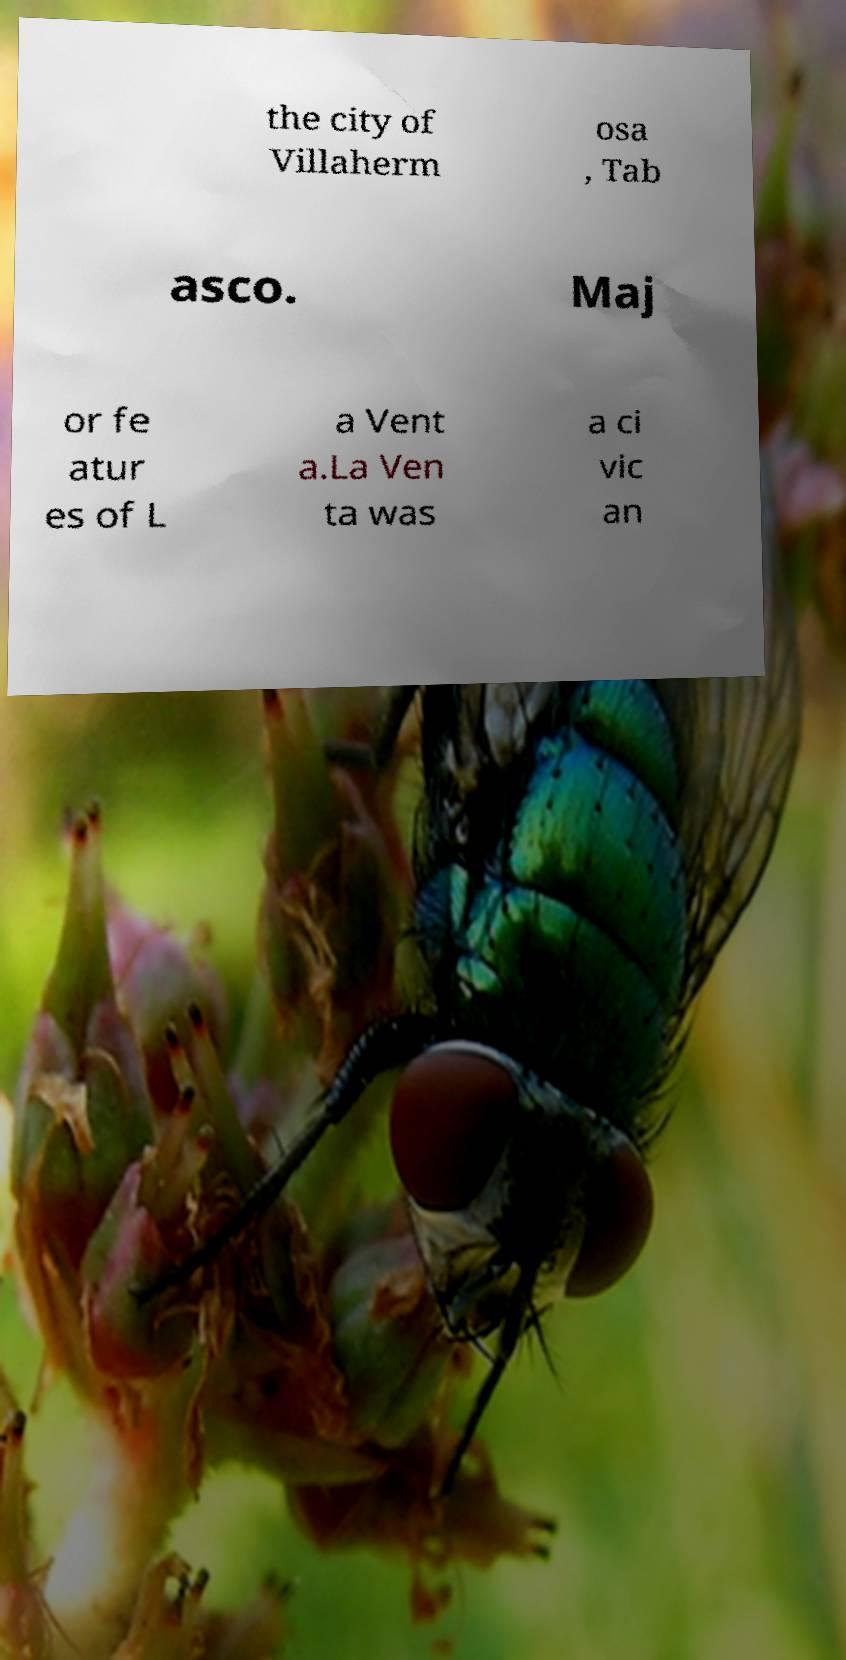Please identify and transcribe the text found in this image. the city of Villaherm osa , Tab asco. Maj or fe atur es of L a Vent a.La Ven ta was a ci vic an 